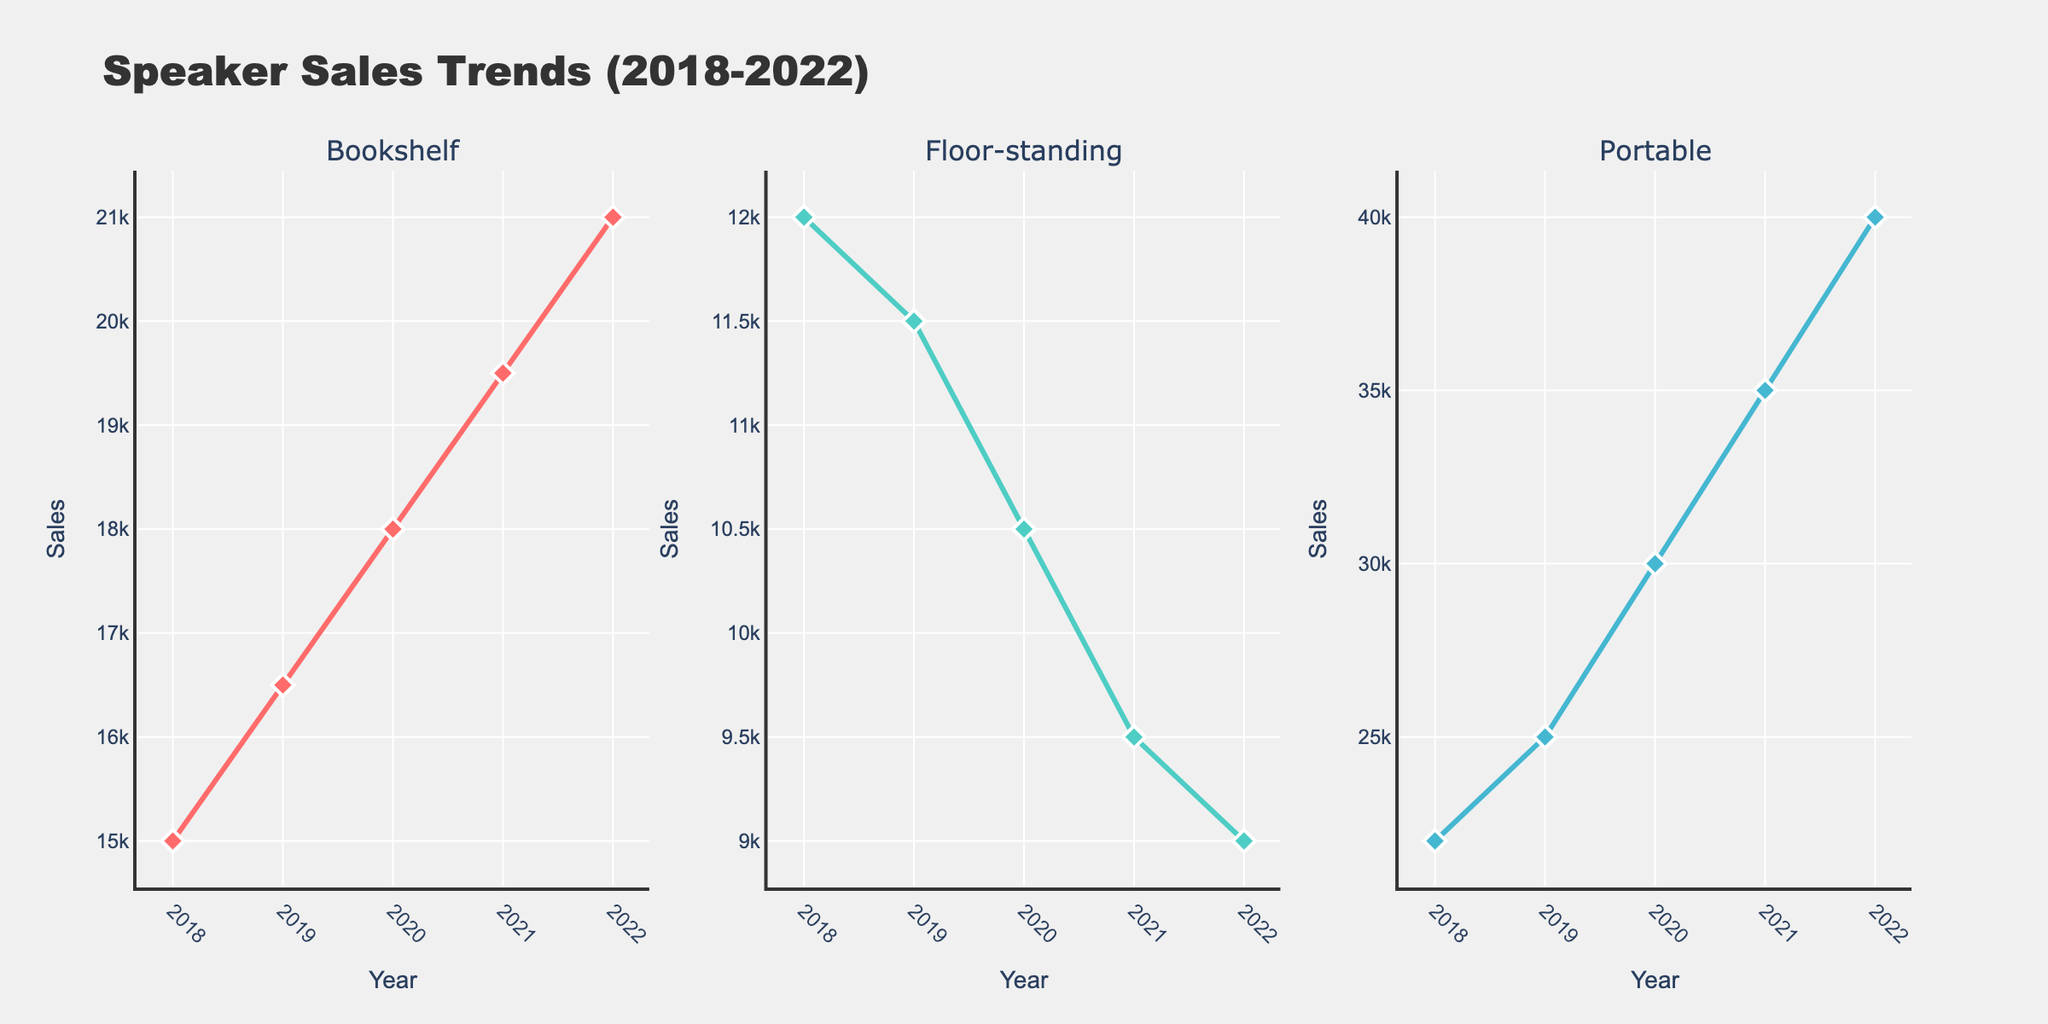How many categories of trustee objections are depicted in the bar chart? The bar chart shows the categories on the x-axis. Counting them one by one, there are ten categories.
Answer: 10 Which year had the highest number of "Preference Actions" objections? In the bar chart, the bar heights for "Preference Actions" across different years show 2020 has the highest bar. The same can be verified in the other subplots as well.
Answer: 2020 What is the total number of "Fraudulent Transfer Claims" objections reported across all years? Adding up the values for "Fraudulent Transfer Claims" across 2019 (20), 2020 (25), 2021 (28), and 2022 (24): 20 + 25 + 28 + 24 = 97.
Answer: 97 Which objection category has the most significant increase in objections from 2019 to 2022? By comparing the values for each category in 2019 and 2022, "Plan Confirmation Issues" increases from 30 to 38, an increase of 8. "Exemption Challenges" increases from 15 to 25, an increase of 10, which is higher than "Plan Confirmation Issues." Thus, "Exemption Challenges" has the most significant increase.
Answer: Exemption Challenges Which category shows a decrease in objections from 2021 to 2022? Looking at each category in the line chart for the years 2021 and 2022, "Asset Valuation Disputes" goes from 35 to 30 and "Assumption/Rejection of Contracts" goes from 25 to 20. These two categories show a decrease.
Answer: Asset Valuation Disputes and Assumption/Rejection of Contracts Which chart type in the subplot best illustrates trend analysis? Among the chart types (bar chart, line chart, area chart, scatter plot), the line chart is typically best for illustrating trends over time due to its continuous line connections that clearly show the trajectory of the data.
Answer: Line Chart In the scatter plot, which year has the maximum spread in the number of objections across all categories? The scatter plot shows points for each category and year. 2020 shows a significant range, especially with high objection values in "Preference Actions" and low values in "Employment of Professionals."
Answer: 2020 